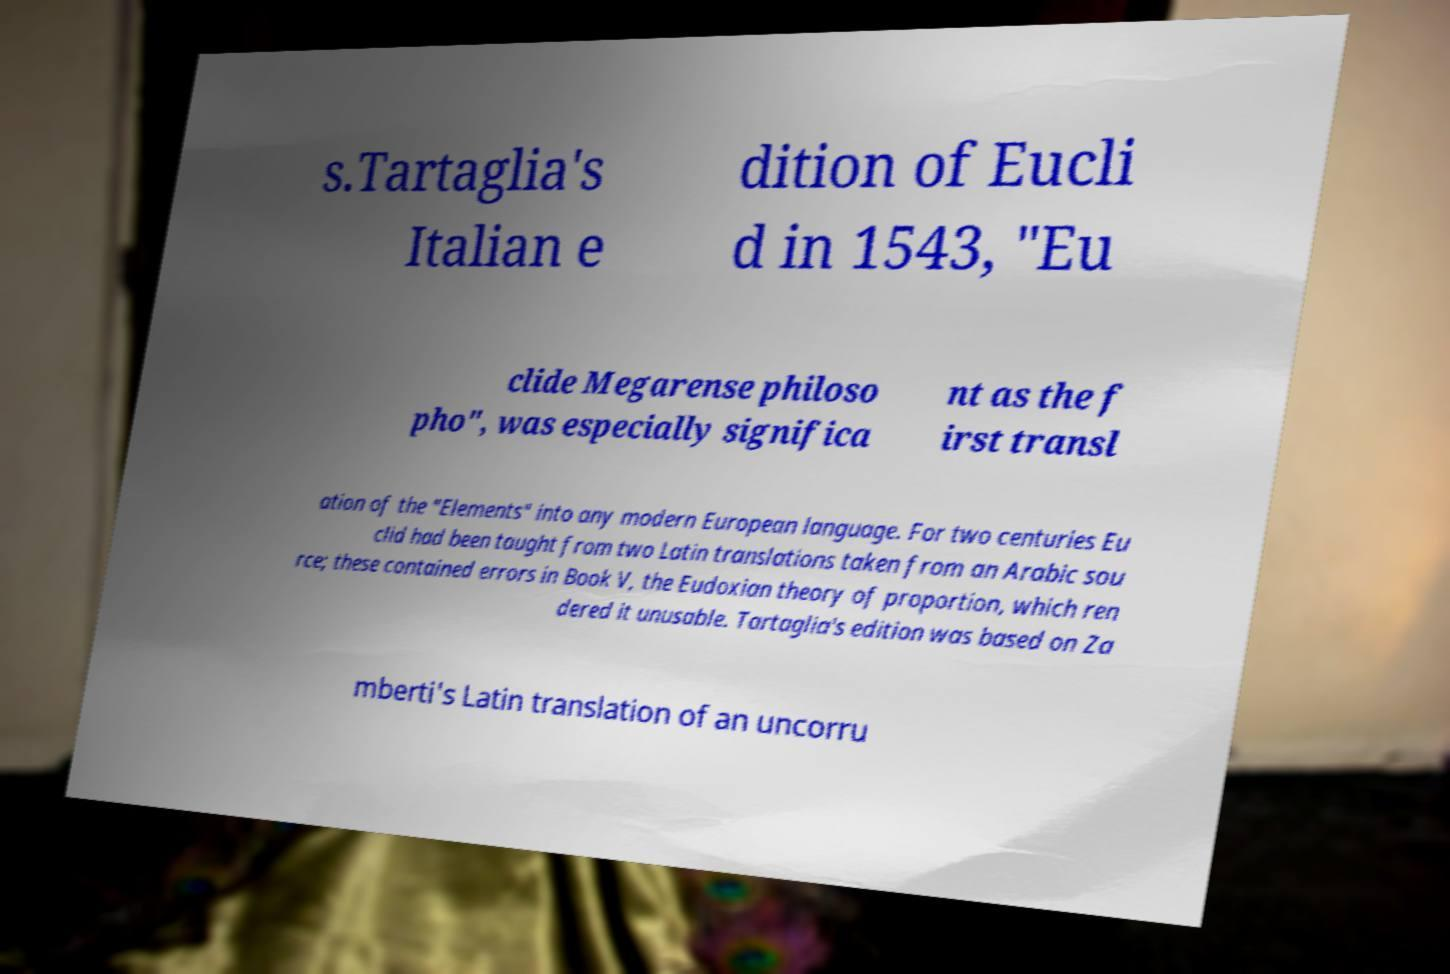Could you assist in decoding the text presented in this image and type it out clearly? s.Tartaglia's Italian e dition of Eucli d in 1543, "Eu clide Megarense philoso pho", was especially significa nt as the f irst transl ation of the "Elements" into any modern European language. For two centuries Eu clid had been taught from two Latin translations taken from an Arabic sou rce; these contained errors in Book V, the Eudoxian theory of proportion, which ren dered it unusable. Tartaglia's edition was based on Za mberti's Latin translation of an uncorru 